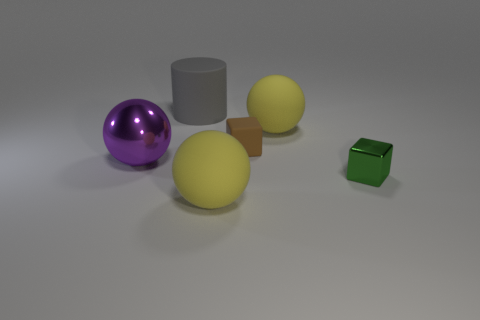Are there an equal number of big yellow spheres that are on the right side of the green thing and small brown metallic things?
Your answer should be compact. Yes. There is a green object that is the same size as the matte cube; what shape is it?
Offer a very short reply. Cube. What is the gray object made of?
Offer a terse response. Rubber. What is the color of the thing that is both to the right of the brown cube and in front of the big purple metallic ball?
Give a very brief answer. Green. Is the number of large gray rubber objects in front of the large matte cylinder the same as the number of tiny brown things to the left of the big purple thing?
Ensure brevity in your answer.  Yes. What is the color of the other thing that is the same material as the big purple thing?
Your response must be concise. Green. There is a small matte cube; is it the same color as the tiny cube in front of the large purple shiny sphere?
Provide a short and direct response. No. There is a yellow matte ball in front of the metallic object right of the large shiny ball; is there a yellow thing that is behind it?
Your answer should be very brief. Yes. There is a small brown thing that is the same material as the large gray object; what shape is it?
Ensure brevity in your answer.  Cube. Are there any other things that are the same shape as the big gray matte thing?
Your answer should be compact. No. 